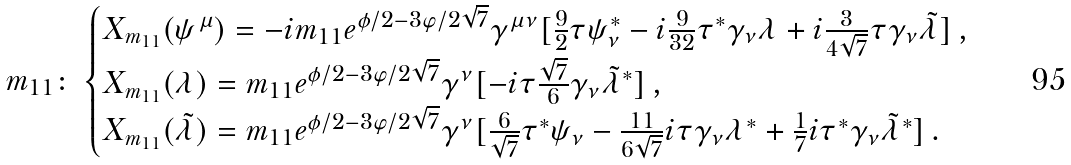<formula> <loc_0><loc_0><loc_500><loc_500>m _ { 1 1 } \colon & \begin{cases} X _ { m _ { 1 1 } } ( \psi ^ { \mu } ) = - i m _ { 1 1 } e ^ { \phi / 2 - 3 \varphi / 2 \sqrt { 7 } } \gamma ^ { \mu \nu } [ \frac { 9 } { 2 } \tau \psi _ { \nu } ^ { * } - i \frac { 9 } { 3 2 } \tau ^ { * } \gamma _ { \nu } \lambda + i \frac { 3 } { 4 \sqrt { 7 } } \tau \gamma _ { \nu } \tilde { \lambda } ] \, , \\ X _ { m _ { 1 1 } } ( \lambda ) = m _ { 1 1 } e ^ { \phi / 2 - 3 \varphi / 2 \sqrt { 7 } } \gamma ^ { \nu } [ - i \tau \frac { \sqrt { 7 } } { 6 } \gamma _ { \nu } \tilde { \lambda } ^ { * } ] \, , \\ X _ { m _ { 1 1 } } ( \tilde { \lambda } ) = m _ { 1 1 } e ^ { \phi / 2 - 3 \varphi / 2 \sqrt { 7 } } \gamma ^ { \nu } [ \frac { 6 } { \sqrt { 7 } } \tau ^ { * } \psi _ { \nu } - \frac { 1 1 } { 6 \sqrt { 7 } } i \tau \gamma _ { \nu } \lambda ^ { * } + \frac { 1 } { 7 } i \tau ^ { * } \gamma _ { \nu } \tilde { \lambda } ^ { * } ] \, . \end{cases}</formula> 